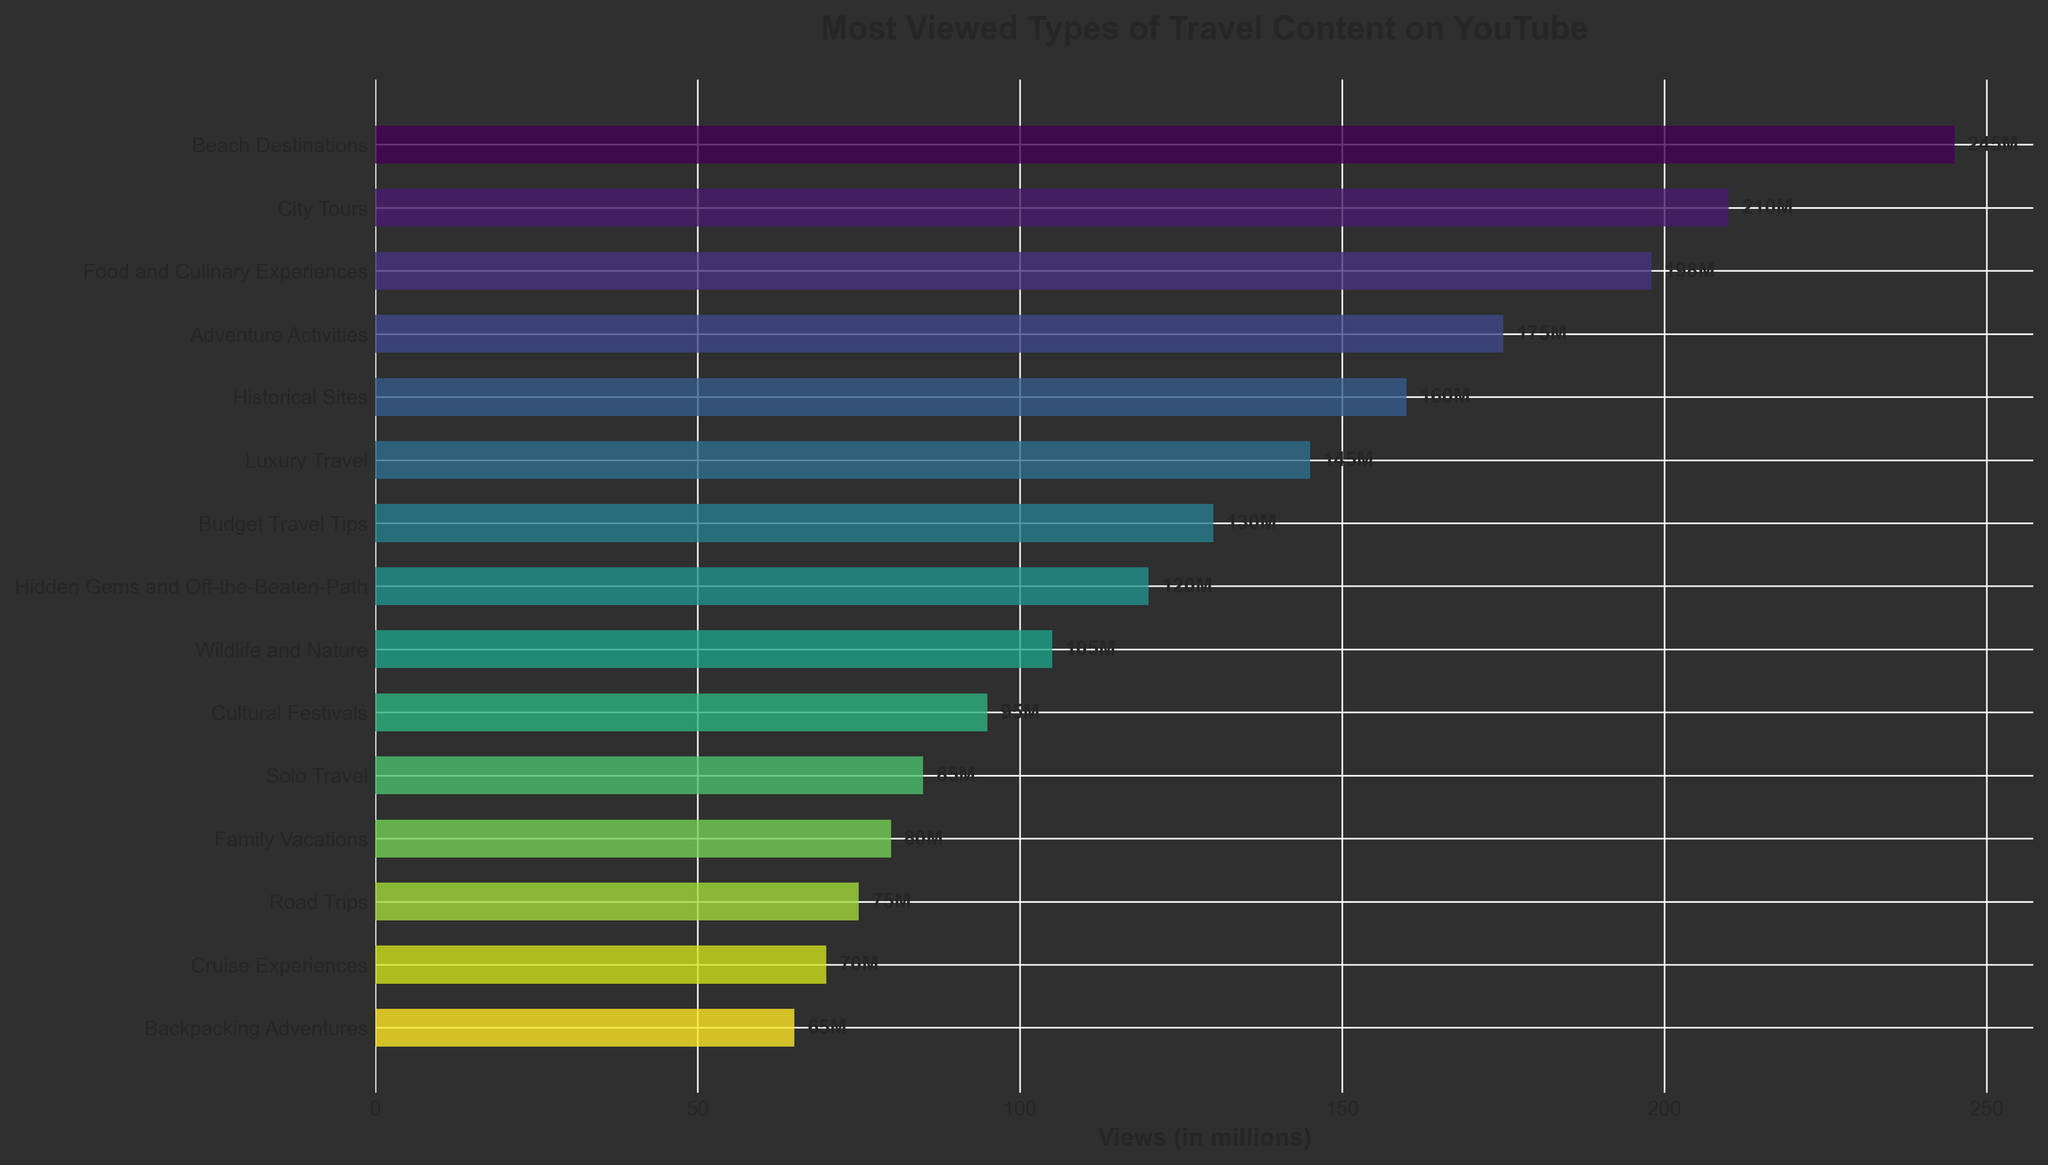What's the most viewed type of travel content on YouTube? The bar for "Beach Destinations" extends the farthest in the horizontal direction, indicating it has the highest number of views.
Answer: Beach Destinations Which travel content category has the least views? The bar for "Backpacking Adventures" is the shortest, indicating it has the fewest views.
Answer: Backpacking Adventures How many views separate "Food and Culinary Experiences" from "City Tours"? "City Tours" has 210 million views, and "Food and Culinary Experiences" has 198 million views. The difference is 210 - 198 = 12 million views.
Answer: 12 million What is the combined view count for "Solo Travel" and "Family Vacations"? "Solo Travel" has 85 million views and "Family Vacations" has 80 million views. Their combined views are 85 + 80 = 165 million.
Answer: 165 million Which category has more views, "Cultural Festivals" or "Wildlife and Nature"? "Wildlife and Nature" has 105 million views, while "Cultural Festivals" has 95 million views. Therefore, "Wildlife and Nature" has more views.
Answer: Wildlife and Nature What is the average number of views for the top five categories? The top five categories are "Beach Destinations" (245M), "City Tours" (210M), "Food and Culinary Experiences" (198M), "Adventure Activities" (175M), and "Historical Sites" (160M). The average is (245 + 210 + 198 + 175 + 160) / 5 = 988 / 5 = 197.6 million views.
Answer: 197.6 million views Which category ranks higher in views, "Luxury Travel" or "Budget Travel Tips"? "Luxury Travel" has 145 million views, while "Budget Travel Tips" has 130 million views. Therefore, "Luxury Travel" has a higher view count.
Answer: Luxury Travel What is the total view count for all categories shown in the figure? The sum of all the views (245 + 210 + 198 + 175 + 160 + 145 + 130 + 120 + 105 + 95 + 85 + 80 + 75 + 70 + 65) = 1,958 million views.
Answer: 1,958 million views Which three categories fall in the middle in terms of views? Ordering the categories by views, the middle three are "Hidden Gems and Off-the-Beaten-Path" (120M), "Wildlife and Nature" (105M), and "Cultural Festivals" (95M).
Answer: Hidden Gems and Off-the-Beaten-Path, Wildlife and Nature, Cultural Festivals 